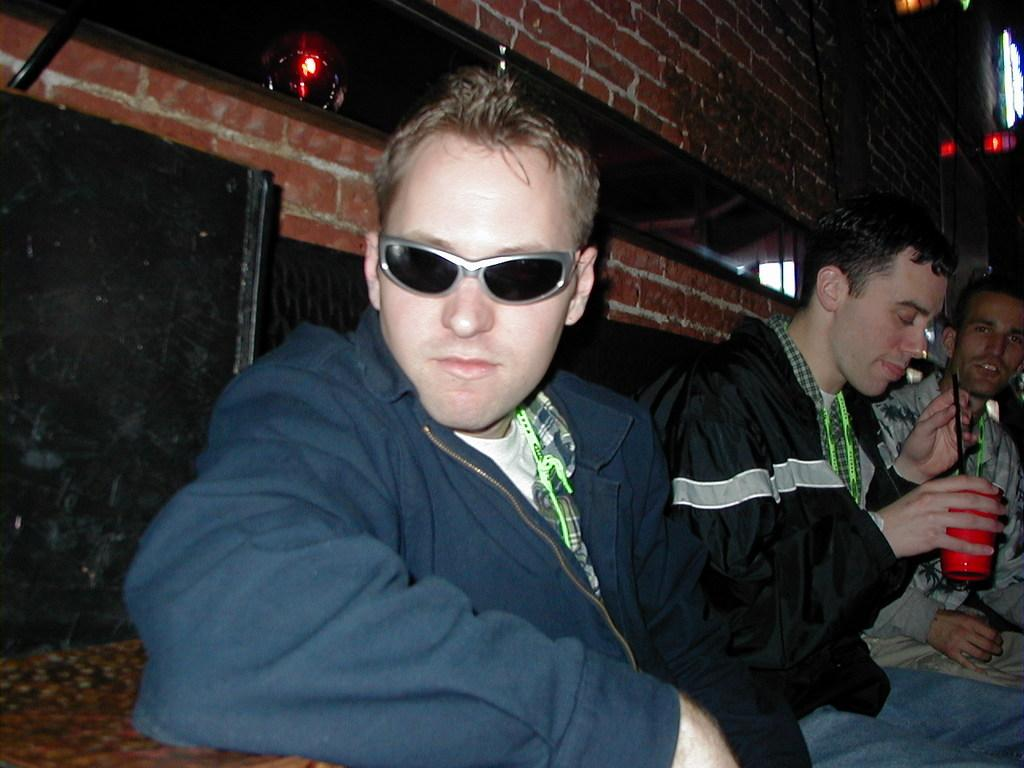How many people are present in the image? There are three people in the image. Can you describe any specific features of one of the people? One person is wearing goggles. What is the other person holding in the image? Another person is holding a glass with a black object. What can be seen in the background of the image? There is a brick wall in the background of the image. What type of crack is visible in the image? There is no crack visible in the image; it features three people and a brick wall in the background. 